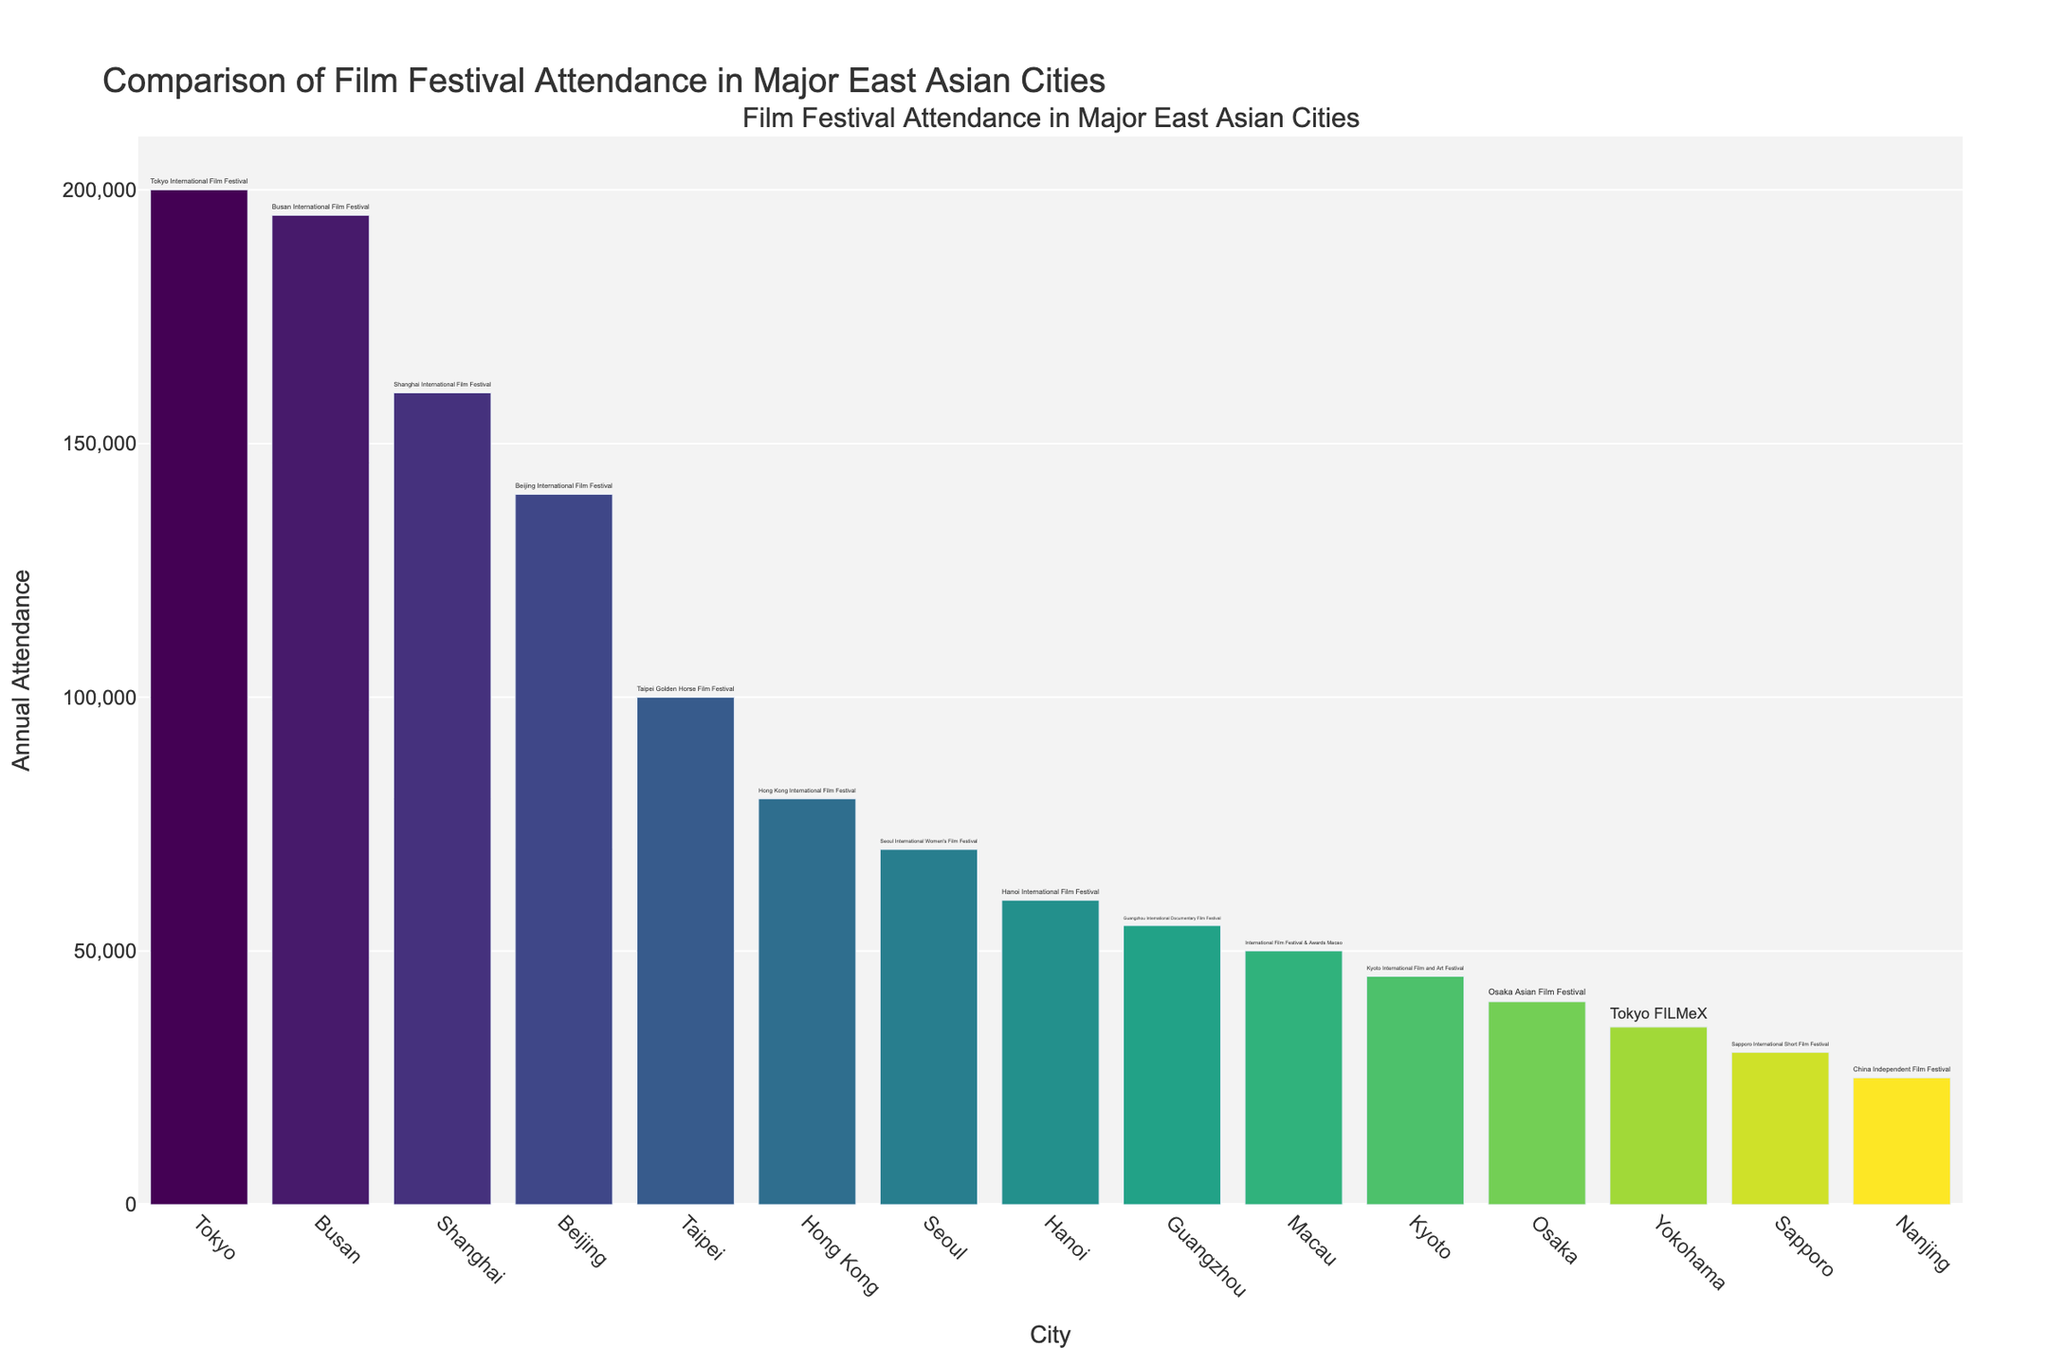Which city has the highest annual attendance for its film festival? The highest bar in the chart represents Tokyo, indicating it has the highest annual attendance.
Answer: Tokyo Which city has a higher attendance, Hong Kong or Macau? Compare the heights of the bars representing Hong Kong and Macau. Hong Kong's bar is taller, indicating a higher attendance.
Answer: Hong Kong What is the total annual attendance for film festivals in Tokyo, Busan, and Shanghai combined? Sum the attendance numbers for Tokyo (200,000), Busan (195,000), and Shanghai (160,000). The total is 200,000 + 195,000 + 160,000 = 555,000.
Answer: 555,000 How much greater is the annual attendance in Tokyo compared to Taipei? Subtract the attendance of Taipei (100,000) from the attendance of Tokyo (200,000). The difference is 200,000 - 100,000 = 100,000.
Answer: 100,000 Which city has the lowest annual attendance for its film festival? The shortest bar in the chart represents Nanjing, indicating it has the lowest annual attendance.
Answer: Nanjing Which two cities have an annual attendance difference of 5,000 for their film festivals? Compare the attendance numbers of all cities to find pairs with a 5,000 difference. Tokyo (200,000) and Busan (195,000) match the condition.
Answer: Tokyo and Busan What is the average annual attendance for the film festivals in Seoul, Macau, Osaka, Guangzhou, and Nanjing? Sum the attendance numbers for Seoul (70,000), Macau (50,000), Osaka (40,000), Guangzhou (55,000), and Nanjing (25,000). The total is 70,000 + 50,000 + 40,000 + 55,000 + 25,000 = 240,000. Divide by 5 to get the average: 240,000 / 5 = 48,000.
Answer: 48,000 How much lower is the annual attendance in Kyoto compared to Shanghai? Subtract the attendance of Kyoto (45,000) from the attendance of Shanghai (160,000). The difference is 160,000 - 45,000 = 115,000.
Answer: 115,000 What is the median annual attendance of all the cities listed? List all attendance numbers in ascending order: 25,000, 30,000, 35,000, 40,000, 45,000, 50,000, 55,000, 60,000, 70,000, 80,000, 100,000, 140,000, 160,000, 195,000, 200,000. The median value (the 8th number in this 15-item list) is 60,000.
Answer: 60,000 